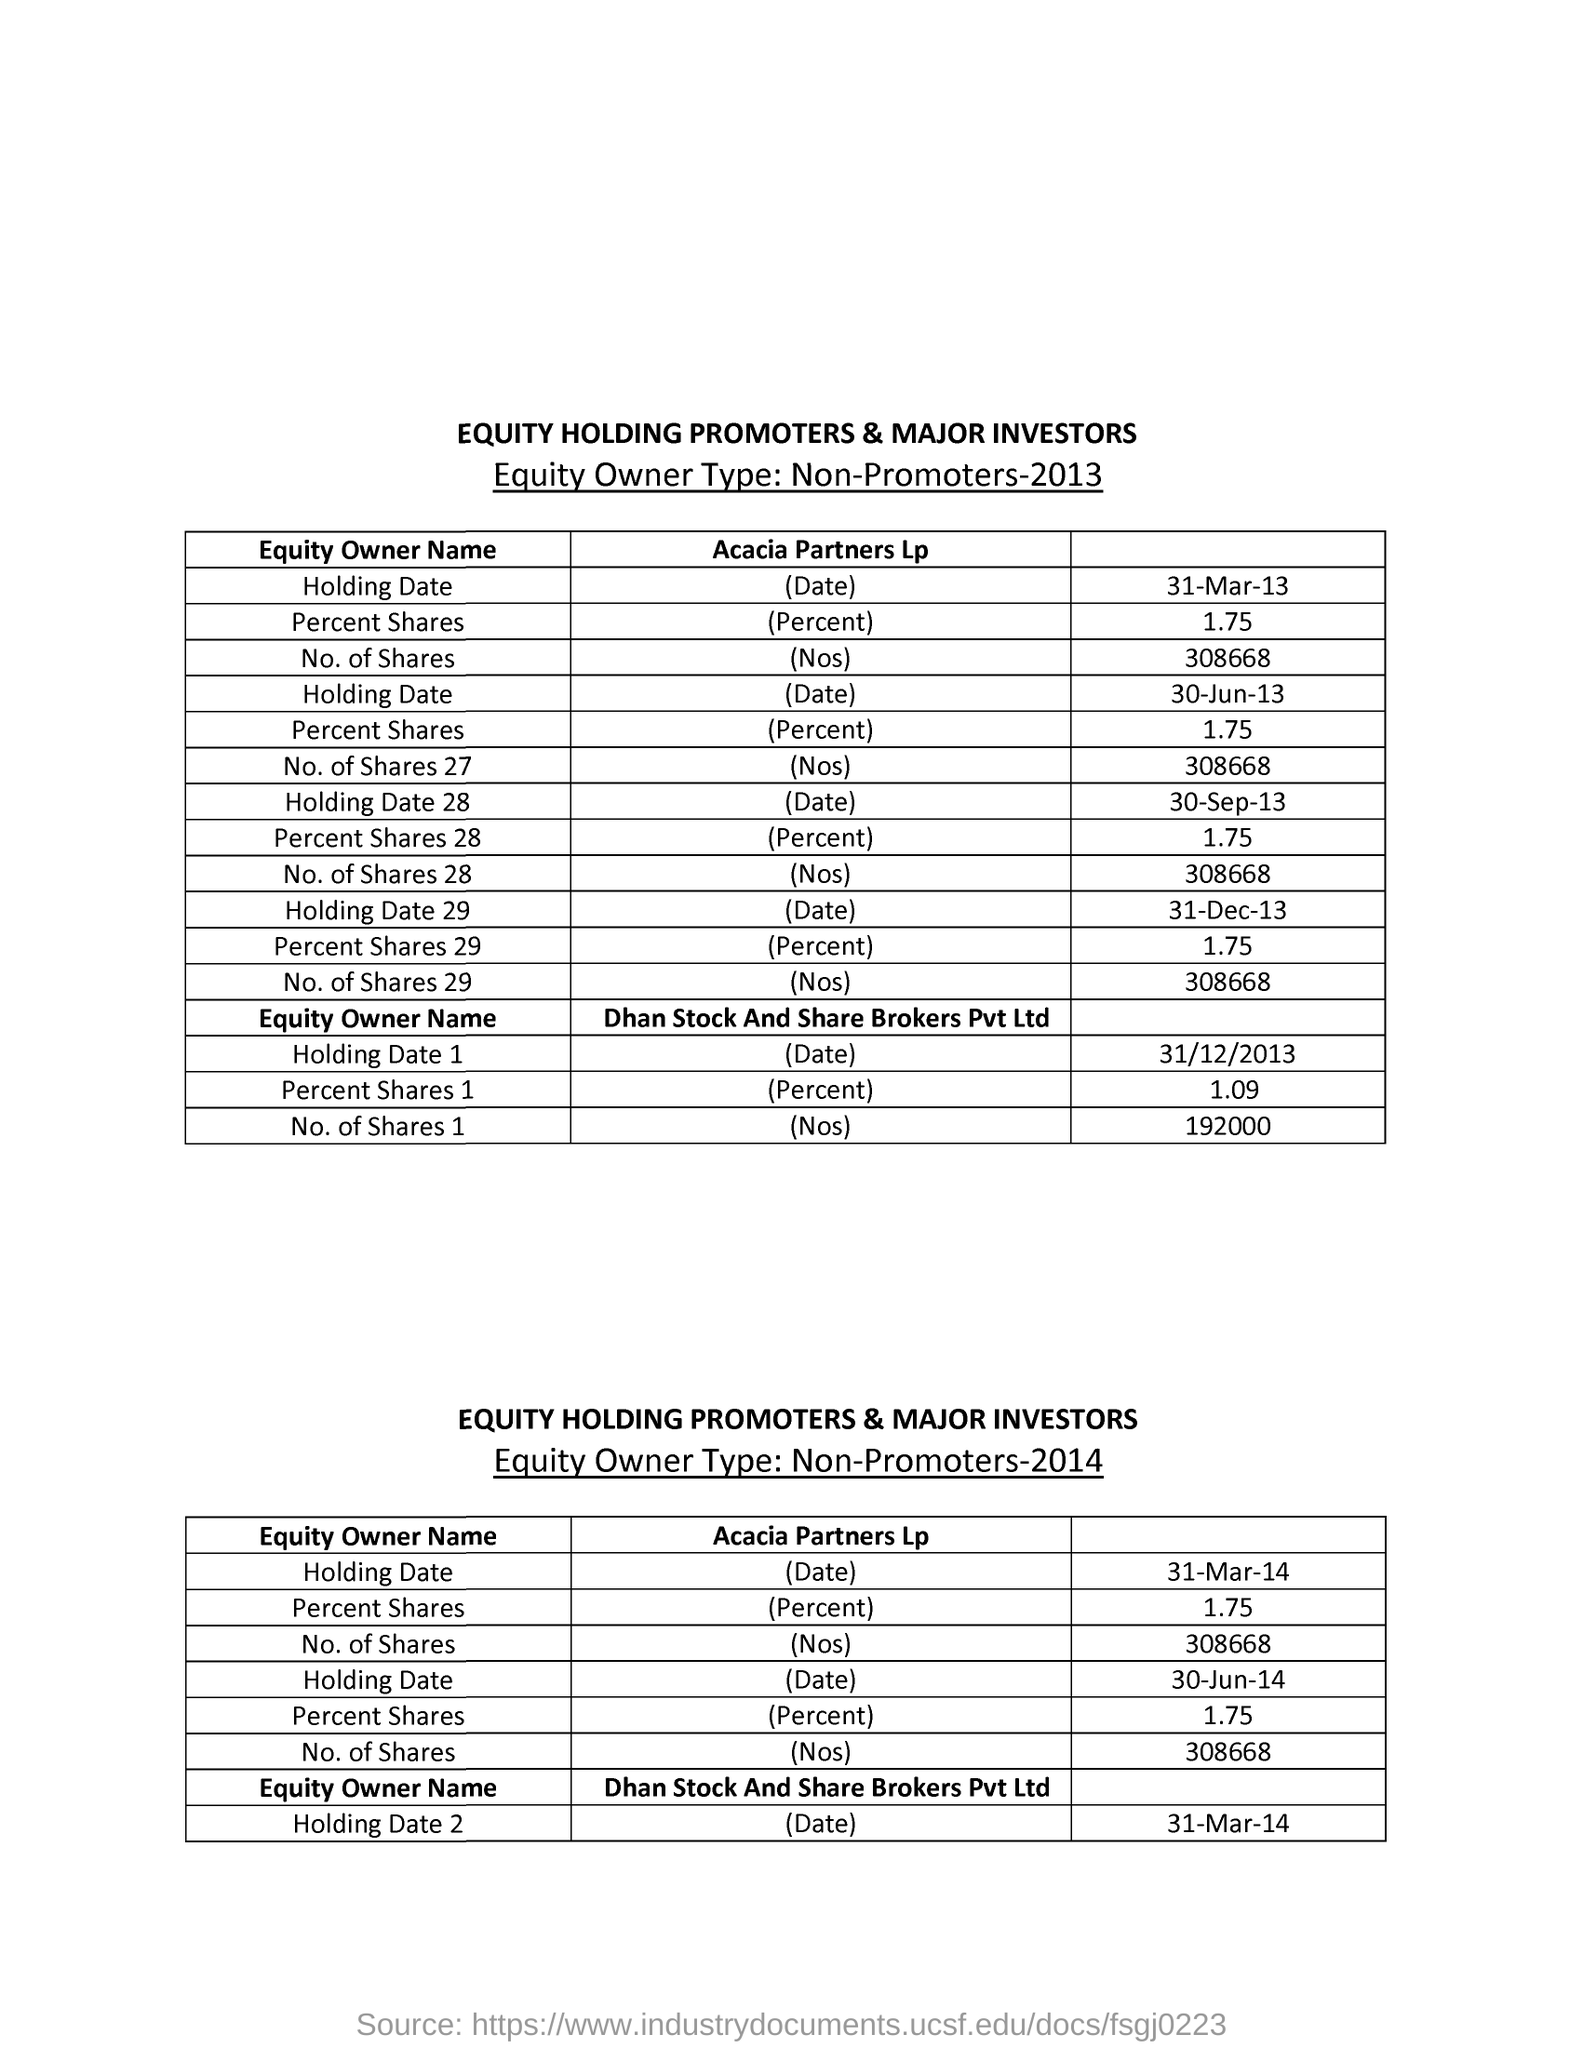What is the percent shares of Acacia Partners Lp for 31-Mar-13?
Keep it short and to the point. 1.75. What is the No. of Shares 1 for Dhan Stock And Share Brokers Pvt Ltd on 31/12/2013?
Ensure brevity in your answer.  192000. 